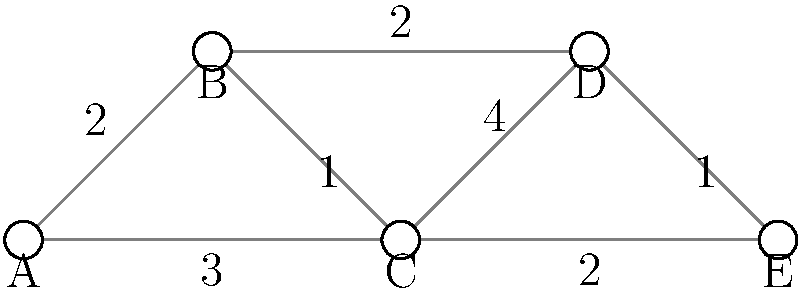In a study on word recognition patterns in dyslexic individuals, a network diagram represents the connections between different areas of the brain involved in language processing. Each node (A, B, C, D, E) represents a specific brain region, and the edges represent neural pathways with weights indicating the strength of connection. What is the total weight of the shortest path from region A to region E? To find the shortest path from region A to region E, we need to consider all possible paths and their total weights. Let's break it down step-by-step:

1. Identify all possible paths from A to E:
   - A -> B -> C -> E
   - A -> B -> D -> E
   - A -> C -> E
   - A -> C -> D -> E

2. Calculate the total weight for each path:
   - A -> B -> C -> E: 2 + 1 + 2 = 5
   - A -> B -> D -> E: 2 + 2 + 1 = 5
   - A -> C -> E: 3 + 2 = 5
   - A -> C -> D -> E: 3 + 4 + 1 = 8

3. Compare the total weights:
   We can see that three paths have the same minimum weight of 5.

4. Identify the shortest path:
   The shortest path is any of the three paths with a total weight of 5. For this question, we only need to provide the total weight of the shortest path.

Therefore, the total weight of the shortest path from region A to region E is 5.
Answer: 5 